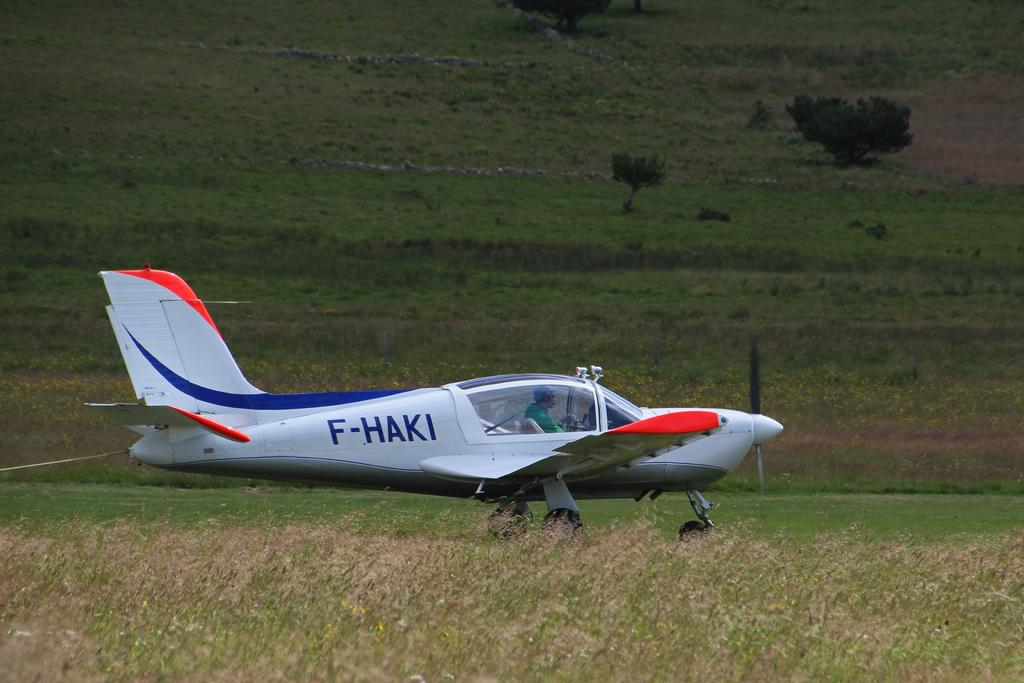What type of vegetation is present in the image? There is dry grass in the image. What is the person in the image doing? The person is sitting in a plane in the image. What can be seen in the background of the image? There is a tree visible in the background of the image. Where is the zebra located in the image? There is no zebra present in the image. What type of building can be seen near the tree in the background? The image does not show any buildings, including a church, near the tree in the background. 